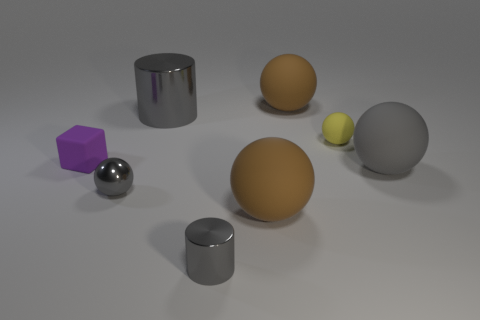Subtract all small gray metallic balls. How many balls are left? 4 Add 1 large brown objects. How many objects exist? 9 Subtract all cylinders. How many objects are left? 6 Subtract 2 cylinders. How many cylinders are left? 0 Subtract all brown spheres. How many spheres are left? 3 Subtract all green cylinders. How many brown balls are left? 2 Subtract all yellow cubes. Subtract all red spheres. How many cubes are left? 1 Subtract all small purple things. Subtract all purple rubber things. How many objects are left? 6 Add 8 gray matte spheres. How many gray matte spheres are left? 9 Add 8 tiny gray shiny cylinders. How many tiny gray shiny cylinders exist? 9 